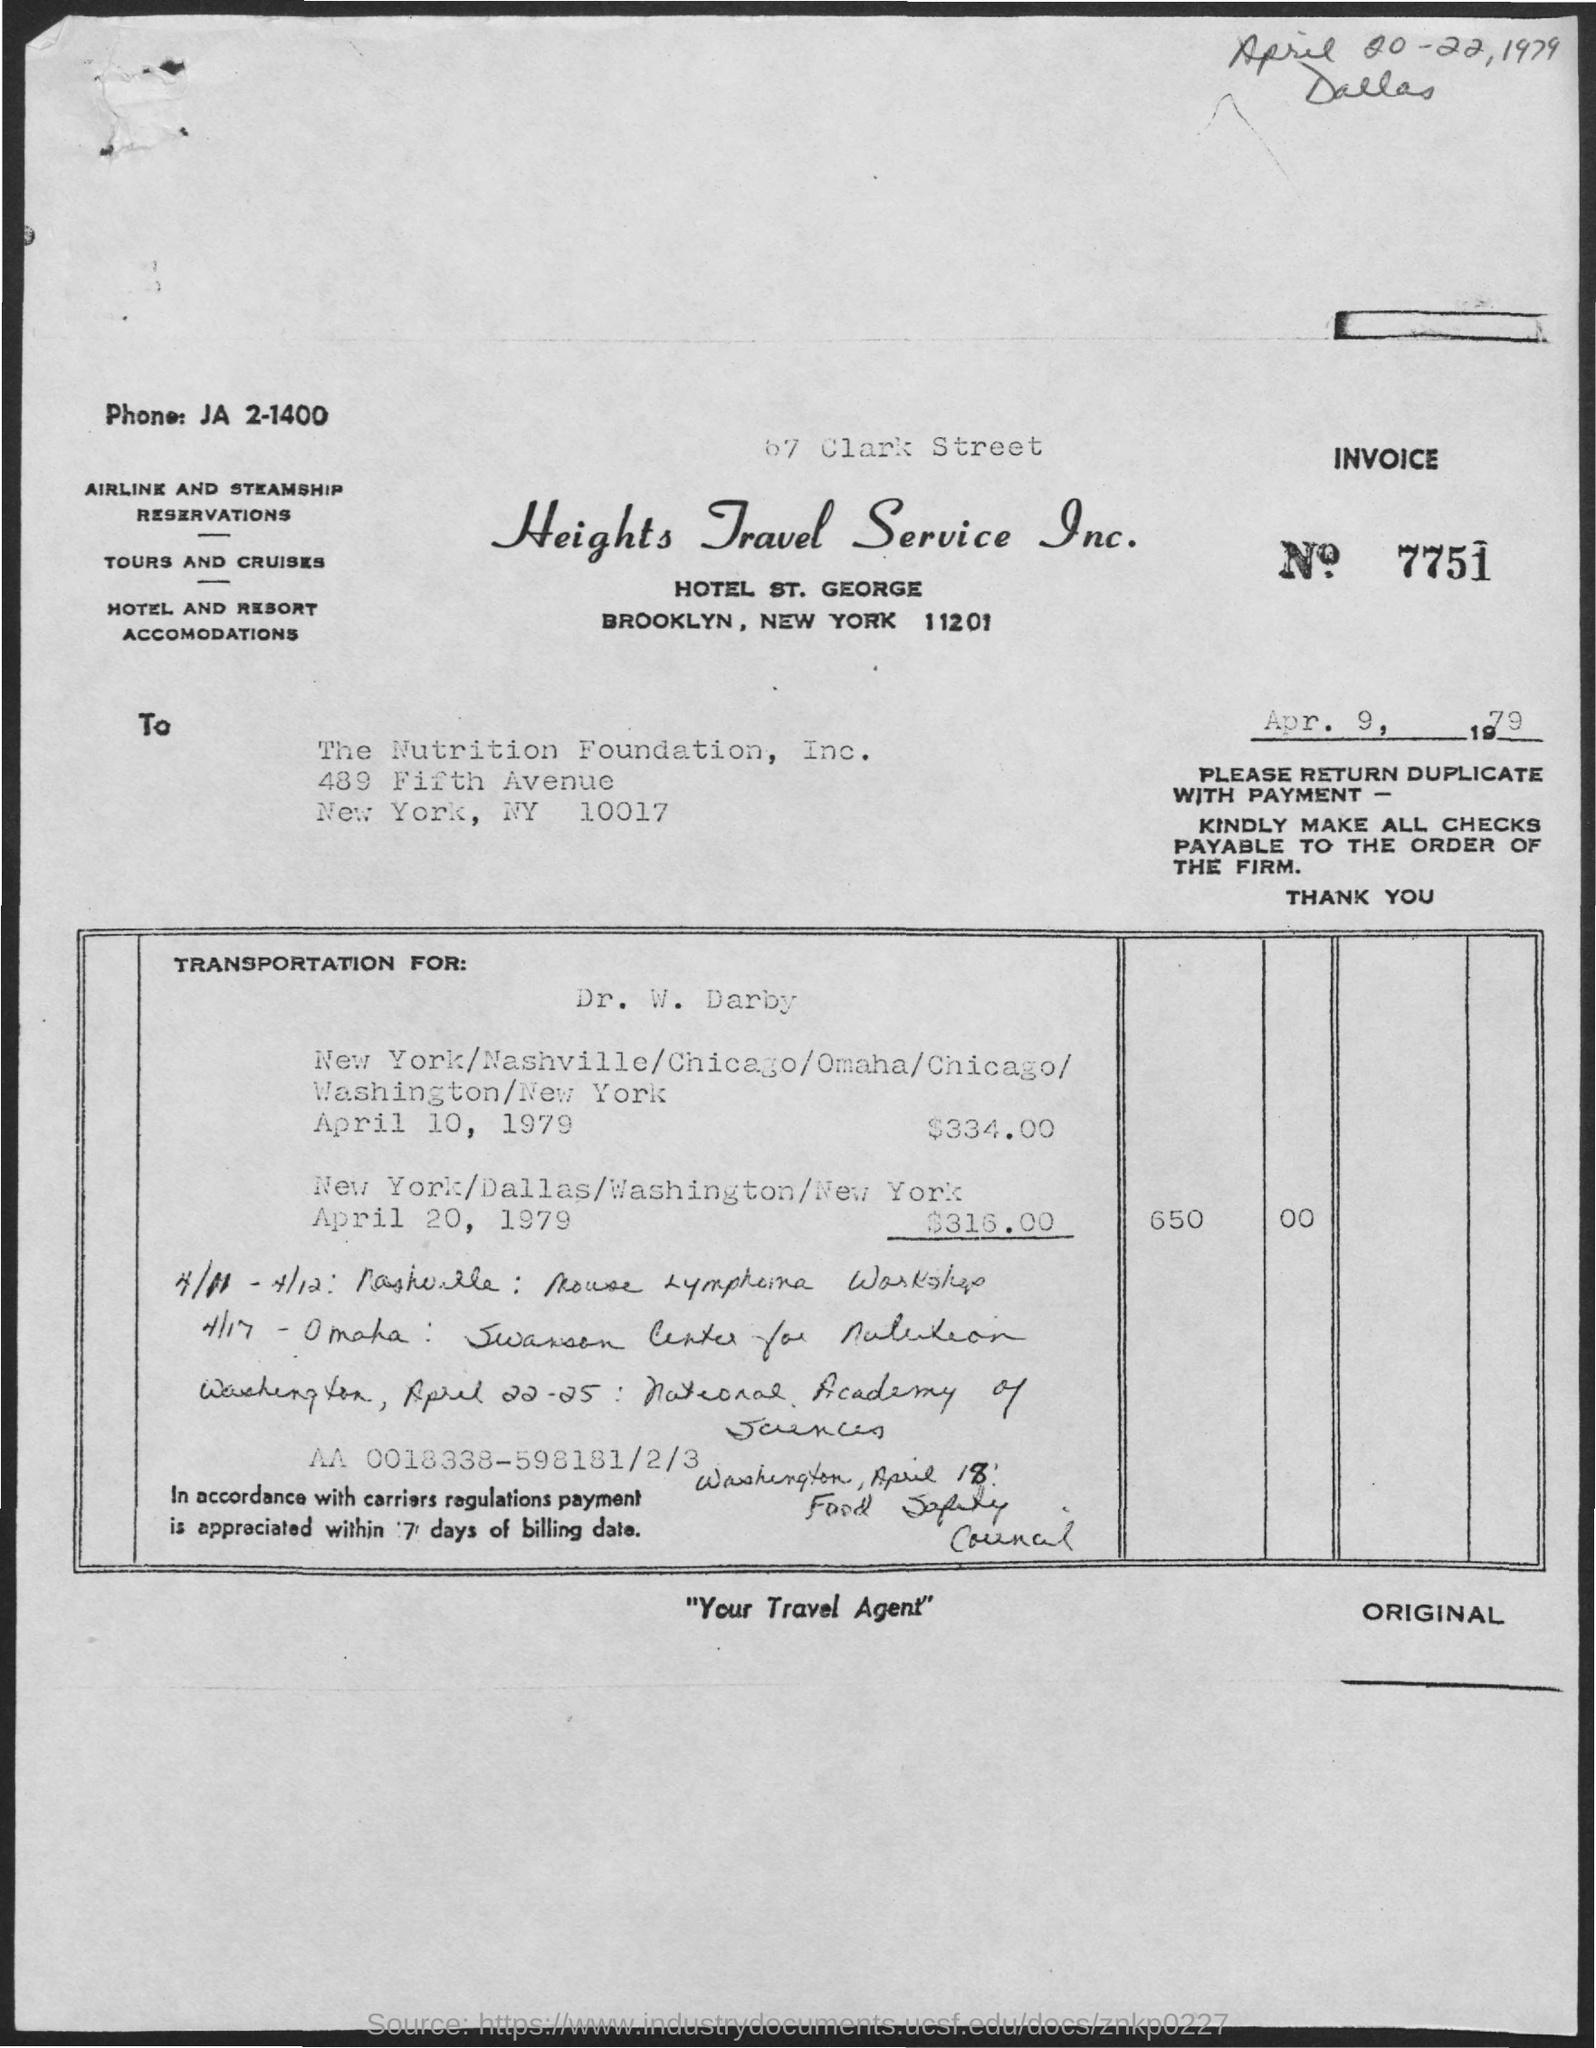What is the invoice number?
Your answer should be compact. 7751. What is the tagline of heights travel service inc. in quotations below?
Your response must be concise. "Your travel agent". 